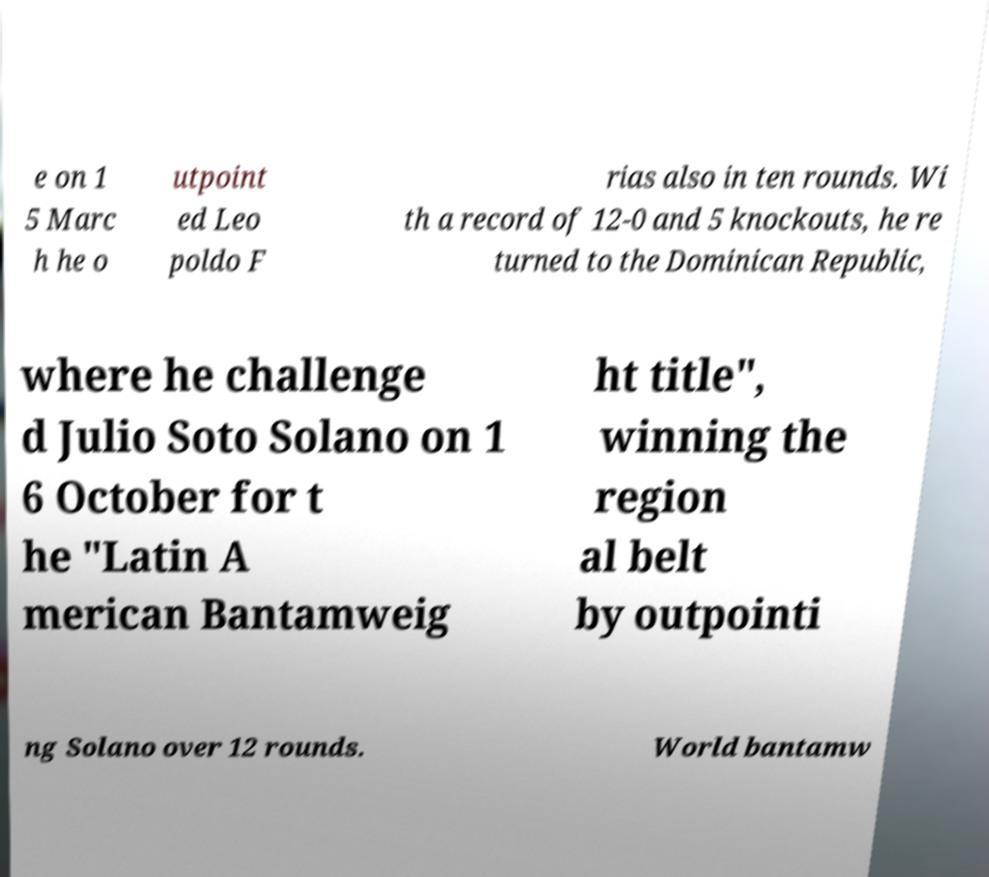There's text embedded in this image that I need extracted. Can you transcribe it verbatim? e on 1 5 Marc h he o utpoint ed Leo poldo F rias also in ten rounds. Wi th a record of 12-0 and 5 knockouts, he re turned to the Dominican Republic, where he challenge d Julio Soto Solano on 1 6 October for t he "Latin A merican Bantamweig ht title", winning the region al belt by outpointi ng Solano over 12 rounds. World bantamw 